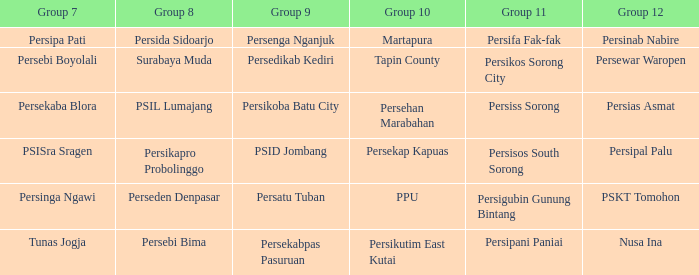Was there only one instance of nusa ina playing when group 7 was playing? 1.0. 